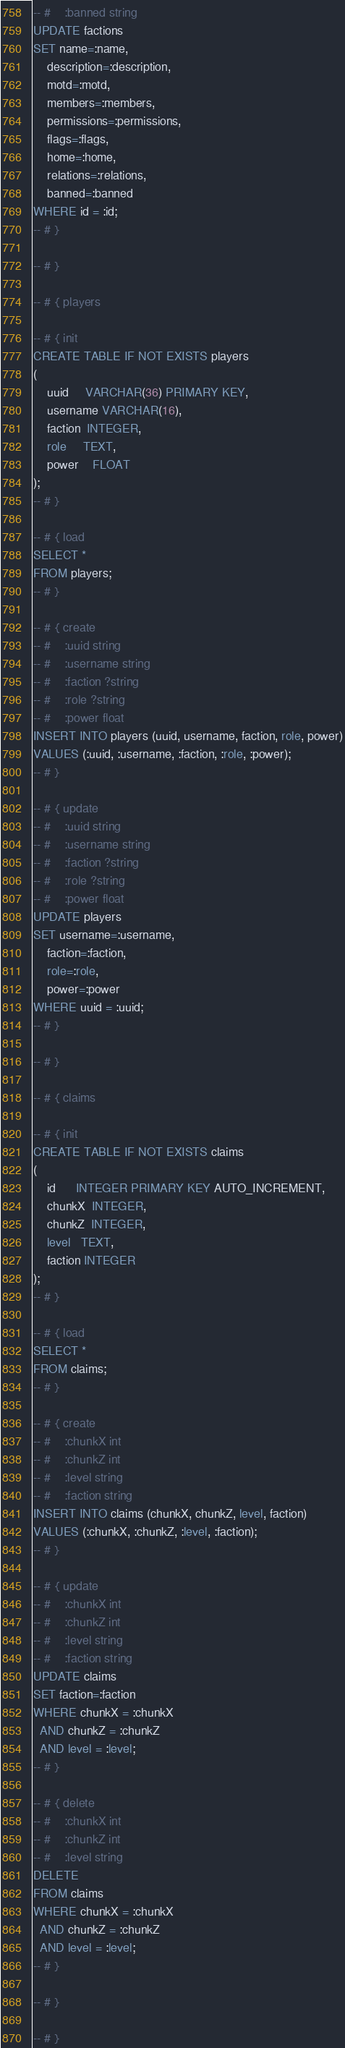Convert code to text. <code><loc_0><loc_0><loc_500><loc_500><_SQL_>-- #    :banned string
UPDATE factions
SET name=:name,
    description=:description,
    motd=:motd,
    members=:members,
    permissions=:permissions,
    flags=:flags,
    home=:home,
    relations=:relations,
    banned=:banned
WHERE id = :id;
-- # }

-- # }

-- # { players

-- # { init
CREATE TABLE IF NOT EXISTS players
(
    uuid     VARCHAR(36) PRIMARY KEY,
    username VARCHAR(16),
    faction  INTEGER,
    role     TEXT,
    power    FLOAT
);
-- # }

-- # { load
SELECT *
FROM players;
-- # }

-- # { create
-- #    :uuid string
-- #    :username string
-- #    :faction ?string
-- #    :role ?string
-- #    :power float
INSERT INTO players (uuid, username, faction, role, power)
VALUES (:uuid, :username, :faction, :role, :power);
-- # }

-- # { update
-- #    :uuid string
-- #    :username string
-- #    :faction ?string
-- #    :role ?string
-- #    :power float
UPDATE players
SET username=:username,
    faction=:faction,
    role=:role,
    power=:power
WHERE uuid = :uuid;
-- # }

-- # }

-- # { claims

-- # { init
CREATE TABLE IF NOT EXISTS claims
(
    id      INTEGER PRIMARY KEY AUTO_INCREMENT,
    chunkX  INTEGER,
    chunkZ  INTEGER,
    level   TEXT,
    faction INTEGER
);
-- # }

-- # { load
SELECT *
FROM claims;
-- # }

-- # { create
-- #    :chunkX int
-- #    :chunkZ int
-- #    :level string
-- #    :faction string
INSERT INTO claims (chunkX, chunkZ, level, faction)
VALUES (:chunkX, :chunkZ, :level, :faction);
-- # }

-- # { update
-- #    :chunkX int
-- #    :chunkZ int
-- #    :level string
-- #    :faction string
UPDATE claims
SET faction=:faction
WHERE chunkX = :chunkX
  AND chunkZ = :chunkZ
  AND level = :level;
-- # }

-- # { delete
-- #    :chunkX int
-- #    :chunkZ int
-- #    :level string
DELETE
FROM claims
WHERE chunkX = :chunkX
  AND chunkZ = :chunkZ
  AND level = :level;
-- # }

-- # }

-- # }</code> 